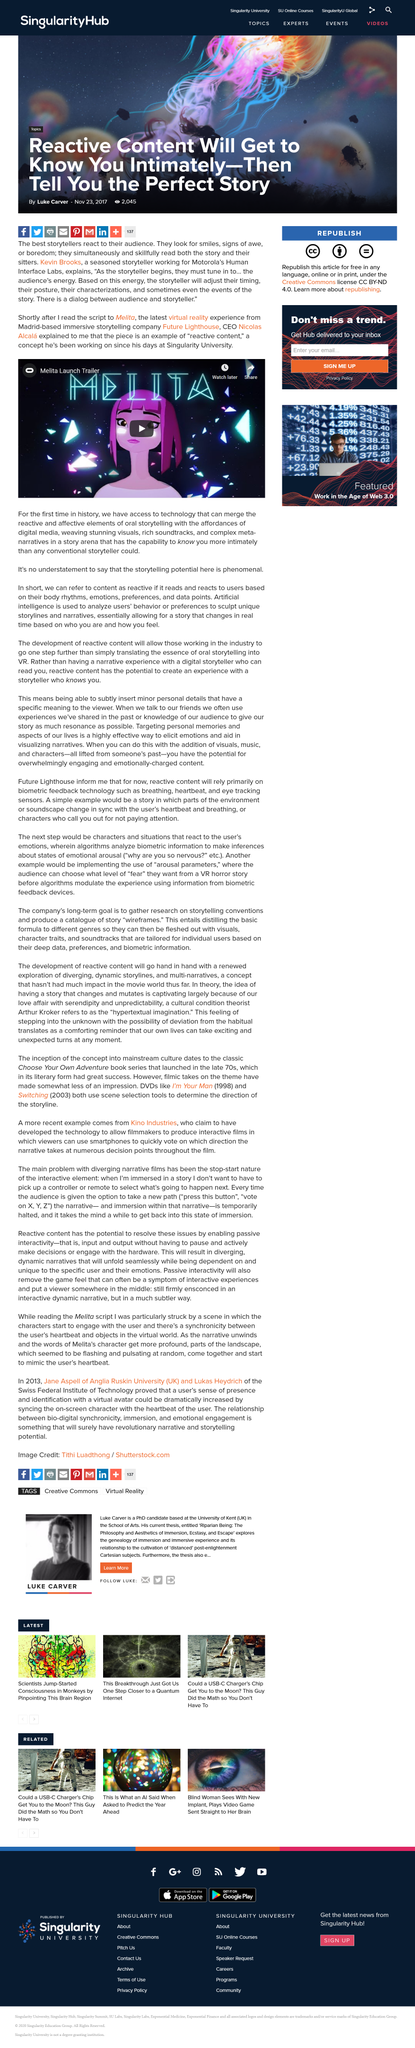Highlight a few significant elements in this photo. Nicolas Alcala is the CEO of Future Lighthouse. The video in question is the Melita Launch Trailer, which is a [insert description of video]. The video is shareable and can be easily disseminated to a wider audience. 